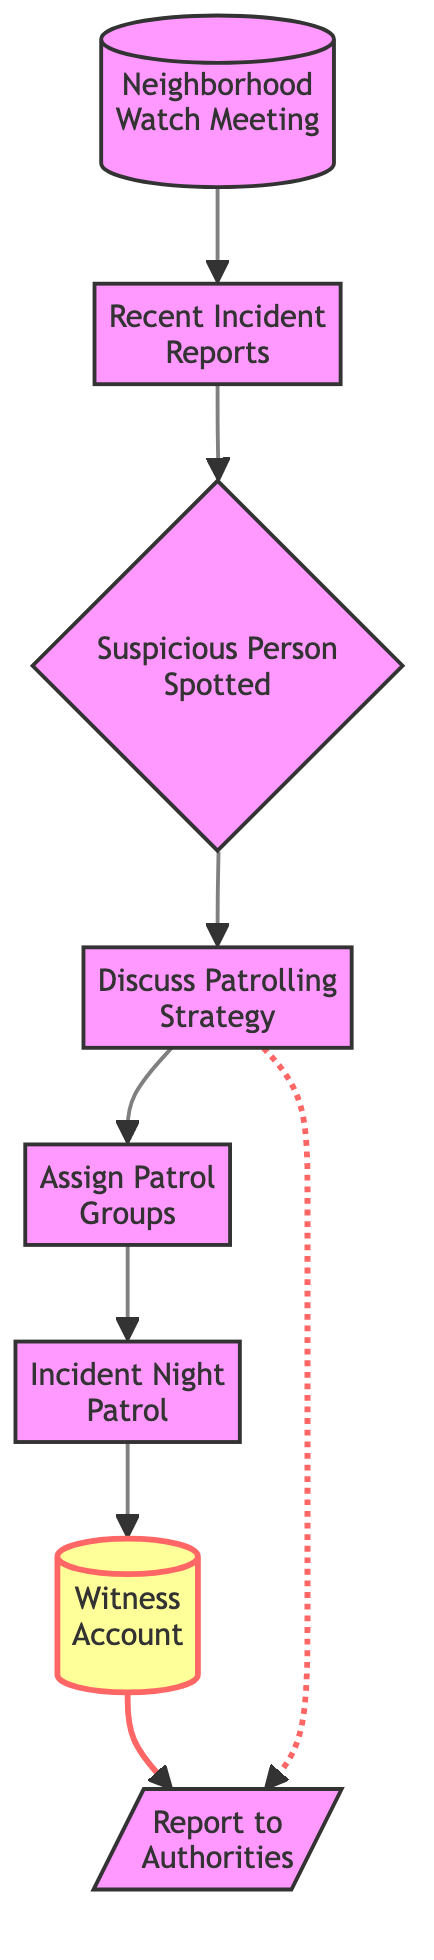What's the total number of nodes in the diagram? The diagram consists of eight nodes that represent various steps in the decision-making process for the Neighborhood Watch. Each unique element in the process is represented as a node.
Answer: 8 What node follows "Discuss Patrolling Strategy"? Following the node "Discuss Patrolling Strategy," the next node is "Assign Patrol Groups." This can be determined by tracing the directed edge from the "Discuss Patrolling Strategy" node to the "Assign Patrol Groups" node.
Answer: Assign Patrol Groups How many edges are there in the diagram? The diagram has a total of seven directed edges. Edges represent the connections or the flow from one node to another, and counting these connections shows how information moves through the process.
Answer: 7 What is the last node in the sequence before reporting to authorities? The last node before reporting to the authorities is "Witness Account." This is identified by tracing the directed edge that leads to the "Report to Authorities" node from "Witness Account."
Answer: Witness Account Which node directly influences the reporting to authorities apart from the witness account? Apart from the "Witness Account," the node "Discuss Patrolling Strategy" also directly influences the "Report to Authorities" node due to the dashed line indicating an alternative path.
Answer: Discuss Patrolling Strategy What node follows "Incident Night Patrol"? The node that follows "Incident Night Patrol" is "Witness Account." This can be identified by looking at the directed edge leading from the "Incident Night Patrol" node to the "Witness Account" node.
Answer: Witness Account Is there a direct connection from "Recent Incident Reports" to "Report to Authorities"? No, there is no direct connection from "Recent Incident Reports" to "Report to Authorities." The flow from "Recent Incident Reports" goes through multiple nodes before reporting to authorities.
Answer: No What step occurs immediately after a suspicious person is spotted? The step that occurs immediately after a suspicious person is spotted is "Discuss Patrolling Strategy," as indicated by the directed edge that connects the two nodes sequentially.
Answer: Discuss Patrolling Strategy Which nodes are tagged with an emphasis style in the diagram? The nodes tagged with an emphasis style are "Witness Account" and "Report to Authorities." The emphasis style highlights these nodes as significant in the decision-making process.
Answer: Witness Account, Report to Authorities 